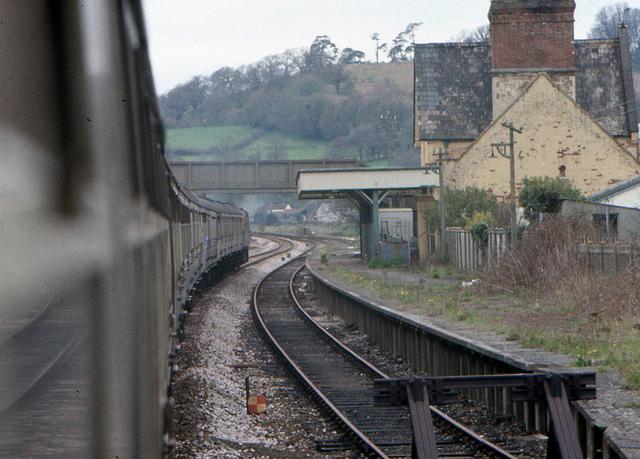Is the building old?
Short answer required. Yes. Is it sunny?
Concise answer only. No. Is there a train on the tracks?
Give a very brief answer. Yes. 